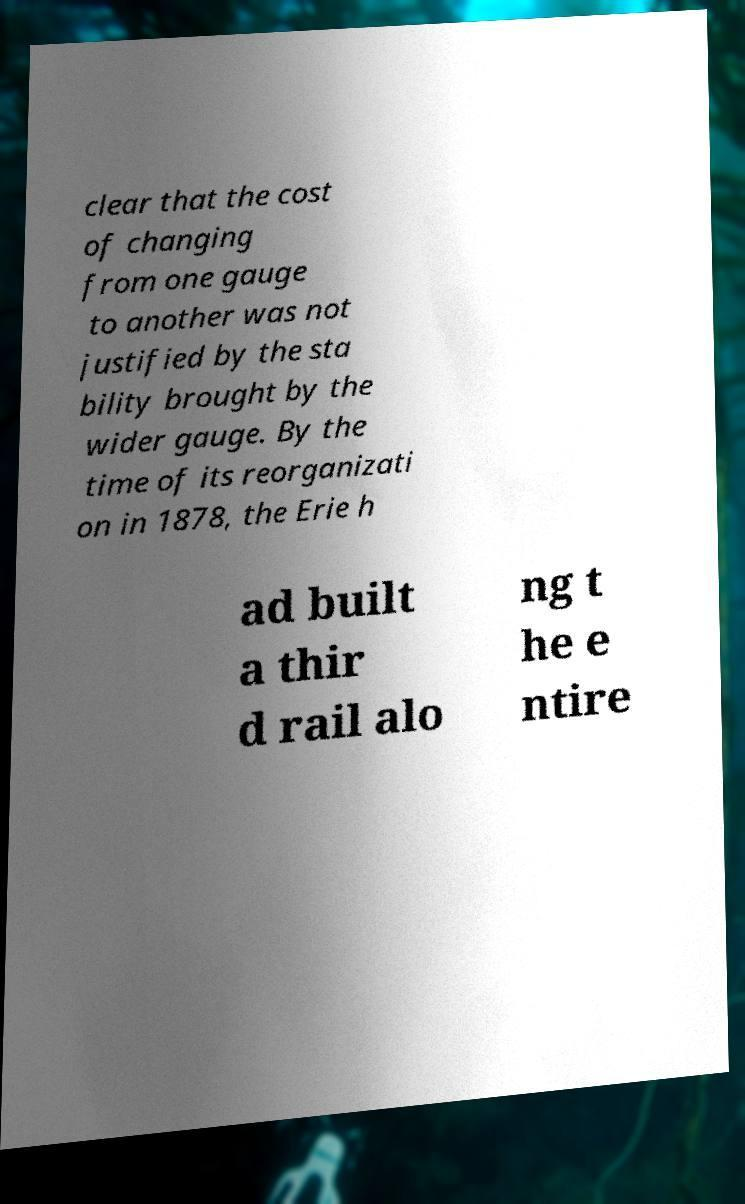Can you accurately transcribe the text from the provided image for me? clear that the cost of changing from one gauge to another was not justified by the sta bility brought by the wider gauge. By the time of its reorganizati on in 1878, the Erie h ad built a thir d rail alo ng t he e ntire 